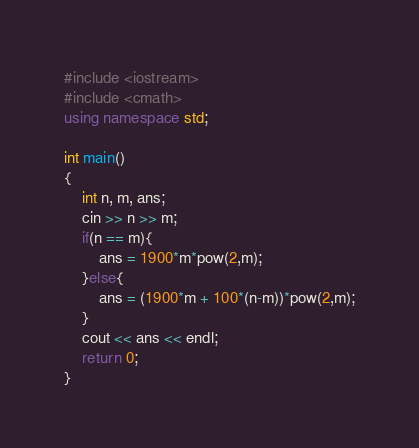Convert code to text. <code><loc_0><loc_0><loc_500><loc_500><_C++_>#include <iostream>
#include <cmath>
using namespace std;

int main()
{
    int n, m, ans;
    cin >> n >> m;
    if(n == m){
        ans = 1900*m*pow(2,m);
    }else{
        ans = (1900*m + 100*(n-m))*pow(2,m);
    }
    cout << ans << endl;
    return 0;
}</code> 